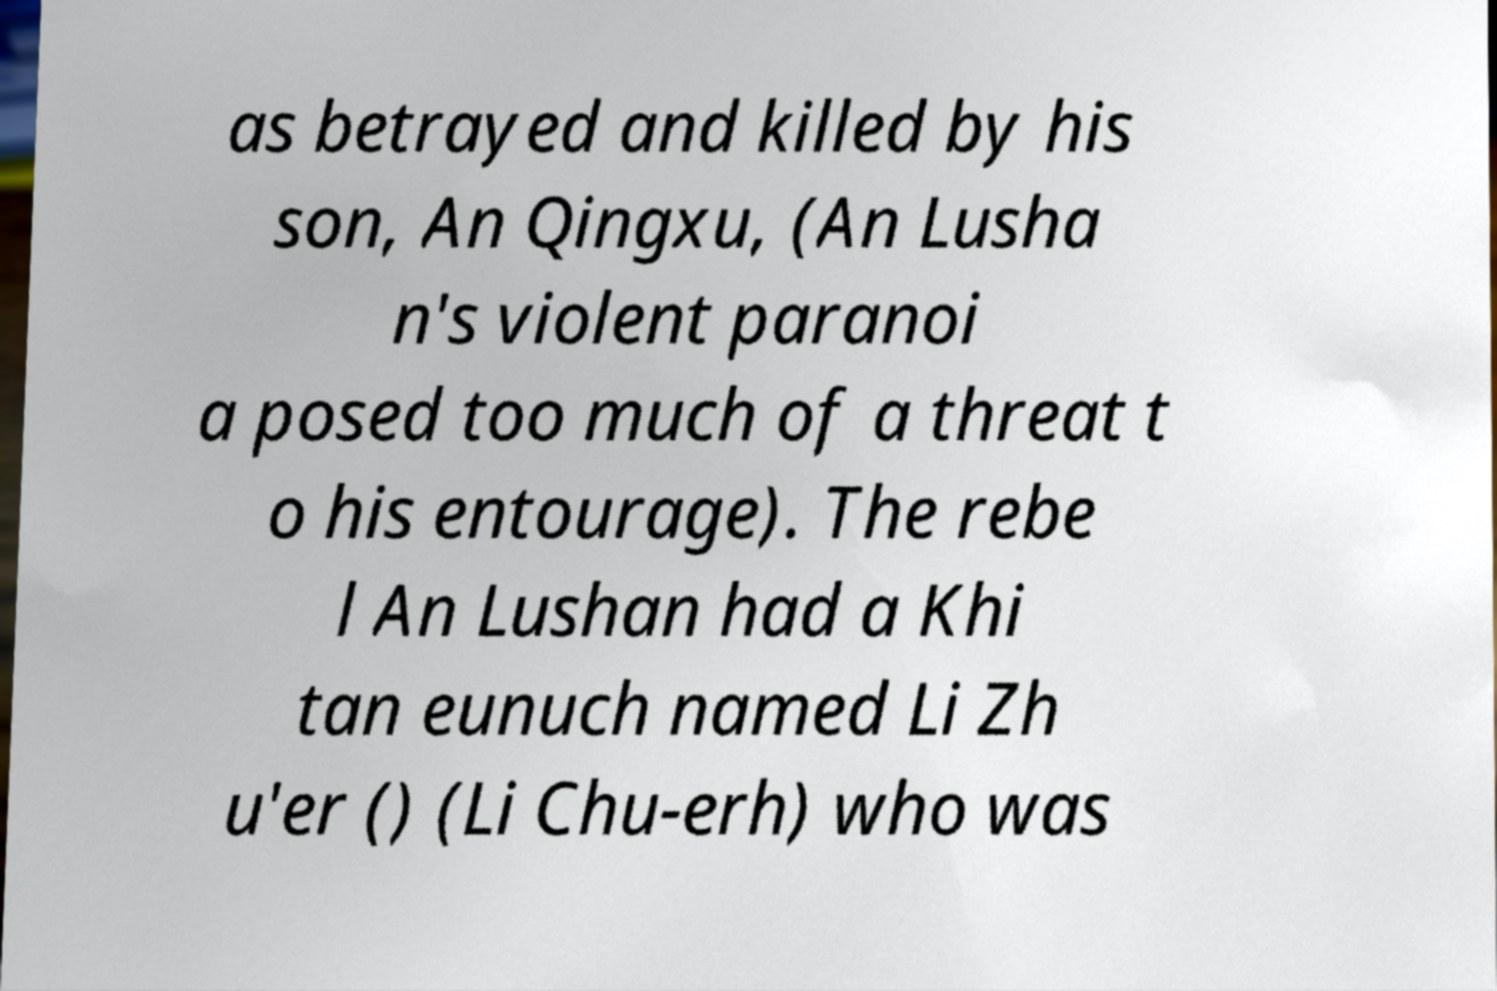There's text embedded in this image that I need extracted. Can you transcribe it verbatim? as betrayed and killed by his son, An Qingxu, (An Lusha n's violent paranoi a posed too much of a threat t o his entourage). The rebe l An Lushan had a Khi tan eunuch named Li Zh u'er () (Li Chu-erh) who was 